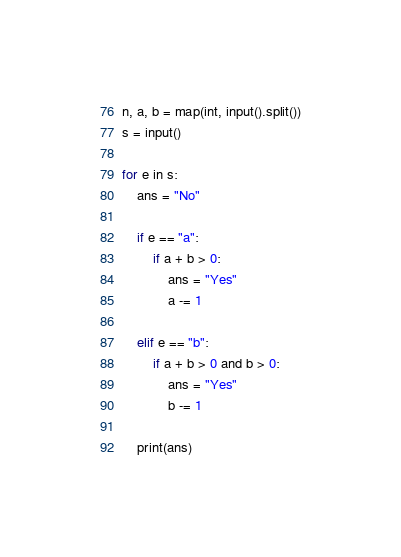<code> <loc_0><loc_0><loc_500><loc_500><_Python_>n, a, b = map(int, input().split())
s = input()

for e in s:
    ans = "No"

    if e == "a":
        if a + b > 0:
            ans = "Yes"
            a -= 1

    elif e == "b":
        if a + b > 0 and b > 0:
            ans = "Yes"
            b -= 1

    print(ans)
</code> 